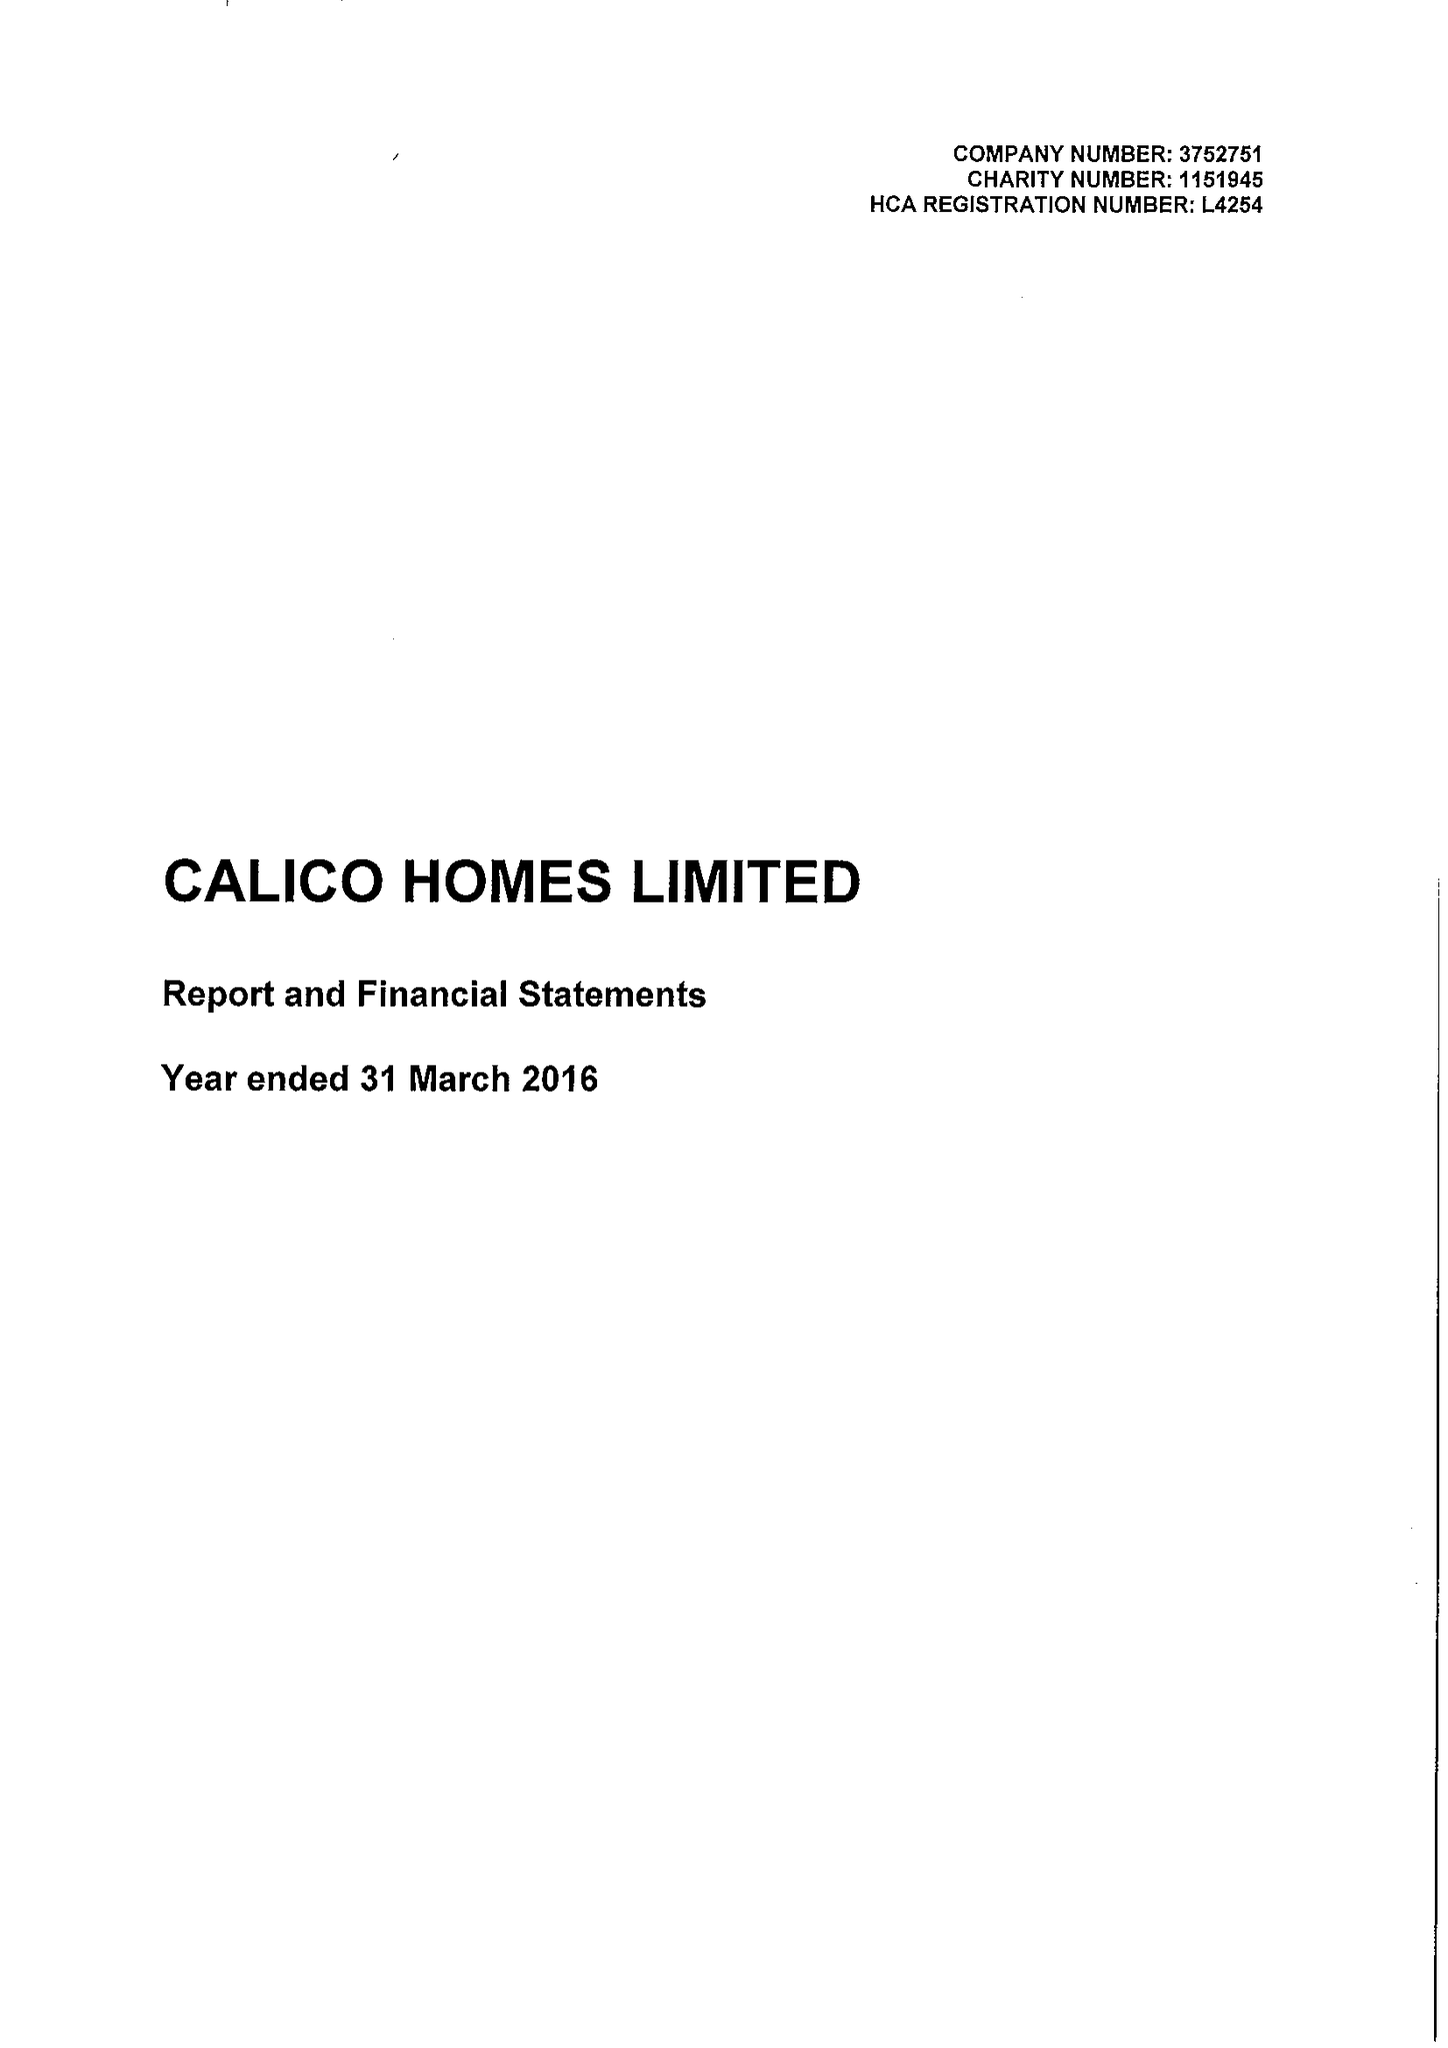What is the value for the address__post_town?
Answer the question using a single word or phrase. BURNLEY 